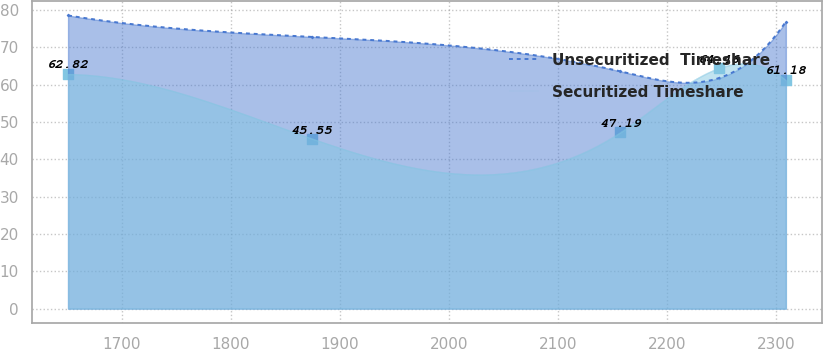<chart> <loc_0><loc_0><loc_500><loc_500><line_chart><ecel><fcel>Unsecuritized  Timeshare<fcel>Securitized Timeshare<nl><fcel>1650.6<fcel>78.53<fcel>62.82<nl><fcel>1874.3<fcel>72.8<fcel>45.55<nl><fcel>2157.18<fcel>63.57<fcel>47.19<nl><fcel>2248.18<fcel>61.79<fcel>64.46<nl><fcel>2309.27<fcel>76.87<fcel>61.18<nl></chart> 